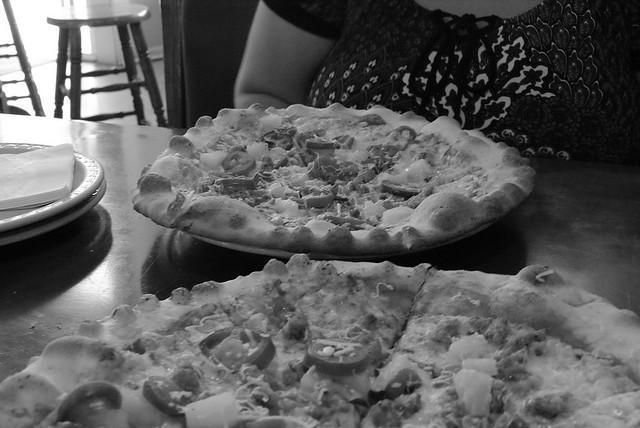How many legs does the stool have?
Give a very brief answer. 4. How many people do you see?
Give a very brief answer. 1. How many chairs are there?
Give a very brief answer. 2. How many people are visible?
Give a very brief answer. 1. How many pizzas can you see?
Give a very brief answer. 3. 